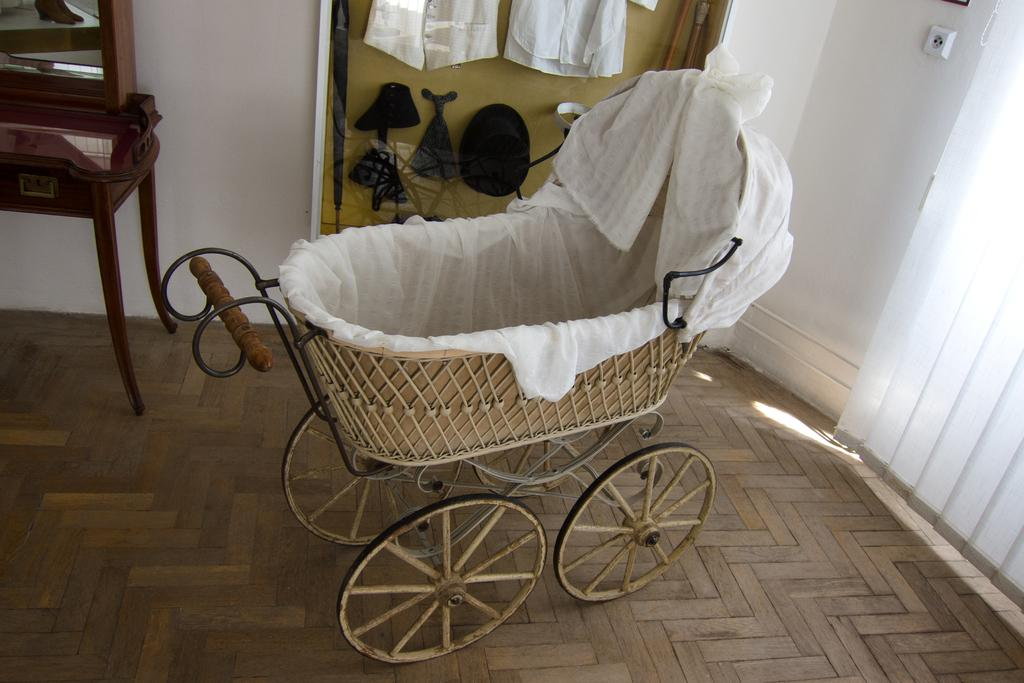What is located on the floor in the image? There is a baby cart on the floor. What can be seen in the background of the image? There is a wall, unspecified things, a wooden object, and a mirror in the background of the image. Can you describe the window treatment in the image? There are window shades on the right side of the image. What type of salt is being used to season the baby cart in the image? There is no salt present in the image, and the baby cart is not a food item to be seasoned. 